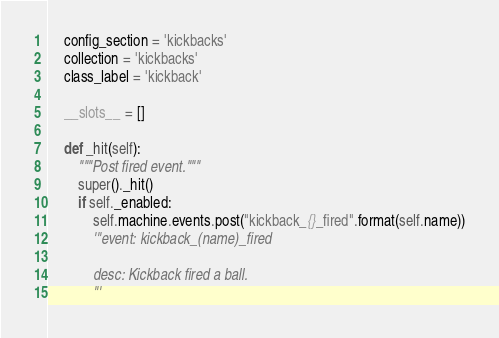<code> <loc_0><loc_0><loc_500><loc_500><_Python_>    config_section = 'kickbacks'
    collection = 'kickbacks'
    class_label = 'kickback'

    __slots__ = []

    def _hit(self):
        """Post fired event."""
        super()._hit()
        if self._enabled:
            self.machine.events.post("kickback_{}_fired".format(self.name))
            '''event: kickback_(name)_fired

            desc: Kickback fired a ball.
            '''
</code> 